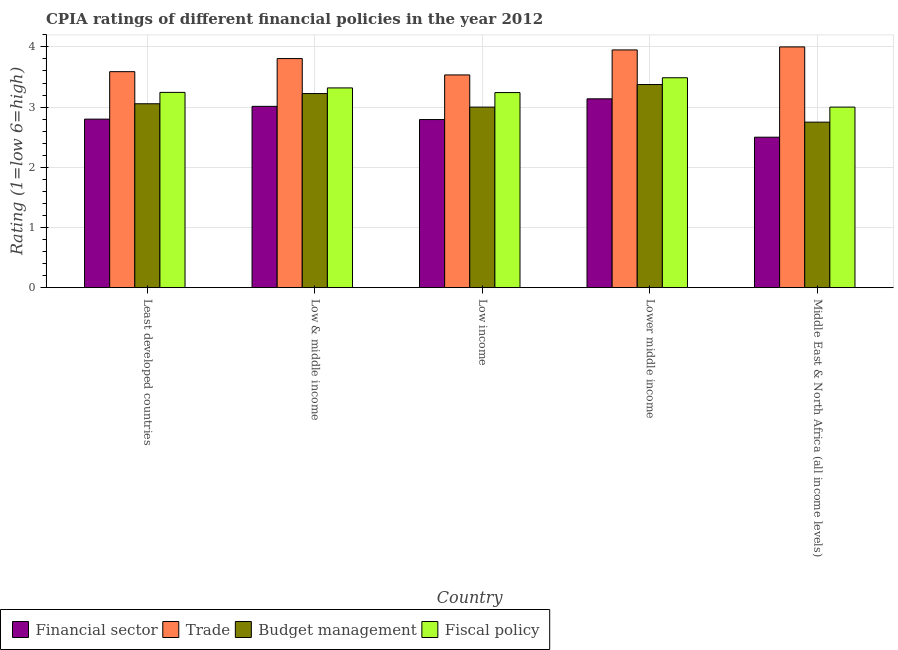Are the number of bars on each tick of the X-axis equal?
Keep it short and to the point. Yes. How many bars are there on the 4th tick from the left?
Ensure brevity in your answer.  4. In how many cases, is the number of bars for a given country not equal to the number of legend labels?
Make the answer very short. 0. What is the cpia rating of fiscal policy in Least developed countries?
Offer a very short reply. 3.24. Across all countries, what is the maximum cpia rating of fiscal policy?
Offer a very short reply. 3.49. Across all countries, what is the minimum cpia rating of fiscal policy?
Keep it short and to the point. 3. In which country was the cpia rating of financial sector maximum?
Ensure brevity in your answer.  Lower middle income. In which country was the cpia rating of financial sector minimum?
Your response must be concise. Middle East & North Africa (all income levels). What is the total cpia rating of trade in the graph?
Offer a very short reply. 18.88. What is the difference between the cpia rating of budget management in Low & middle income and that in Lower middle income?
Provide a short and direct response. -0.15. What is the difference between the cpia rating of fiscal policy in Low & middle income and the cpia rating of trade in Middle East & North Africa (all income levels)?
Offer a very short reply. -0.68. What is the average cpia rating of financial sector per country?
Your answer should be very brief. 2.85. What is the difference between the cpia rating of fiscal policy and cpia rating of financial sector in Low income?
Offer a terse response. 0.45. In how many countries, is the cpia rating of fiscal policy greater than 0.4 ?
Offer a very short reply. 5. What is the ratio of the cpia rating of trade in Least developed countries to that in Lower middle income?
Give a very brief answer. 0.91. What is the difference between the highest and the second highest cpia rating of trade?
Make the answer very short. 0.05. What is the difference between the highest and the lowest cpia rating of trade?
Provide a short and direct response. 0.47. What does the 3rd bar from the left in Low & middle income represents?
Ensure brevity in your answer.  Budget management. What does the 1st bar from the right in Lower middle income represents?
Provide a short and direct response. Fiscal policy. Is it the case that in every country, the sum of the cpia rating of financial sector and cpia rating of trade is greater than the cpia rating of budget management?
Your response must be concise. Yes. How many bars are there?
Provide a short and direct response. 20. Are all the bars in the graph horizontal?
Give a very brief answer. No. What is the difference between two consecutive major ticks on the Y-axis?
Your response must be concise. 1. Are the values on the major ticks of Y-axis written in scientific E-notation?
Provide a succinct answer. No. How are the legend labels stacked?
Your answer should be very brief. Horizontal. What is the title of the graph?
Provide a succinct answer. CPIA ratings of different financial policies in the year 2012. What is the label or title of the X-axis?
Offer a terse response. Country. What is the label or title of the Y-axis?
Ensure brevity in your answer.  Rating (1=low 6=high). What is the Rating (1=low 6=high) in Financial sector in Least developed countries?
Give a very brief answer. 2.8. What is the Rating (1=low 6=high) of Trade in Least developed countries?
Your answer should be compact. 3.59. What is the Rating (1=low 6=high) in Budget management in Least developed countries?
Offer a terse response. 3.06. What is the Rating (1=low 6=high) in Fiscal policy in Least developed countries?
Offer a very short reply. 3.24. What is the Rating (1=low 6=high) of Financial sector in Low & middle income?
Ensure brevity in your answer.  3.01. What is the Rating (1=low 6=high) in Trade in Low & middle income?
Your answer should be compact. 3.81. What is the Rating (1=low 6=high) in Budget management in Low & middle income?
Your answer should be compact. 3.23. What is the Rating (1=low 6=high) in Fiscal policy in Low & middle income?
Offer a terse response. 3.32. What is the Rating (1=low 6=high) in Financial sector in Low income?
Your response must be concise. 2.79. What is the Rating (1=low 6=high) in Trade in Low income?
Give a very brief answer. 3.53. What is the Rating (1=low 6=high) of Budget management in Low income?
Give a very brief answer. 3. What is the Rating (1=low 6=high) in Fiscal policy in Low income?
Provide a succinct answer. 3.24. What is the Rating (1=low 6=high) in Financial sector in Lower middle income?
Provide a succinct answer. 3.14. What is the Rating (1=low 6=high) of Trade in Lower middle income?
Your answer should be compact. 3.95. What is the Rating (1=low 6=high) of Budget management in Lower middle income?
Provide a succinct answer. 3.38. What is the Rating (1=low 6=high) in Fiscal policy in Lower middle income?
Provide a short and direct response. 3.49. What is the Rating (1=low 6=high) of Budget management in Middle East & North Africa (all income levels)?
Keep it short and to the point. 2.75. Across all countries, what is the maximum Rating (1=low 6=high) of Financial sector?
Provide a succinct answer. 3.14. Across all countries, what is the maximum Rating (1=low 6=high) in Trade?
Offer a terse response. 4. Across all countries, what is the maximum Rating (1=low 6=high) in Budget management?
Make the answer very short. 3.38. Across all countries, what is the maximum Rating (1=low 6=high) in Fiscal policy?
Your answer should be very brief. 3.49. Across all countries, what is the minimum Rating (1=low 6=high) of Trade?
Ensure brevity in your answer.  3.53. Across all countries, what is the minimum Rating (1=low 6=high) in Budget management?
Make the answer very short. 2.75. What is the total Rating (1=low 6=high) of Financial sector in the graph?
Provide a short and direct response. 14.24. What is the total Rating (1=low 6=high) of Trade in the graph?
Give a very brief answer. 18.88. What is the total Rating (1=low 6=high) in Budget management in the graph?
Ensure brevity in your answer.  15.41. What is the total Rating (1=low 6=high) of Fiscal policy in the graph?
Make the answer very short. 16.29. What is the difference between the Rating (1=low 6=high) in Financial sector in Least developed countries and that in Low & middle income?
Offer a terse response. -0.21. What is the difference between the Rating (1=low 6=high) of Trade in Least developed countries and that in Low & middle income?
Your answer should be very brief. -0.22. What is the difference between the Rating (1=low 6=high) in Budget management in Least developed countries and that in Low & middle income?
Offer a terse response. -0.17. What is the difference between the Rating (1=low 6=high) of Fiscal policy in Least developed countries and that in Low & middle income?
Your answer should be very brief. -0.07. What is the difference between the Rating (1=low 6=high) of Financial sector in Least developed countries and that in Low income?
Offer a terse response. 0.01. What is the difference between the Rating (1=low 6=high) in Trade in Least developed countries and that in Low income?
Ensure brevity in your answer.  0.05. What is the difference between the Rating (1=low 6=high) in Budget management in Least developed countries and that in Low income?
Provide a short and direct response. 0.06. What is the difference between the Rating (1=low 6=high) of Fiscal policy in Least developed countries and that in Low income?
Ensure brevity in your answer.  0. What is the difference between the Rating (1=low 6=high) in Financial sector in Least developed countries and that in Lower middle income?
Make the answer very short. -0.34. What is the difference between the Rating (1=low 6=high) in Trade in Least developed countries and that in Lower middle income?
Give a very brief answer. -0.36. What is the difference between the Rating (1=low 6=high) of Budget management in Least developed countries and that in Lower middle income?
Keep it short and to the point. -0.32. What is the difference between the Rating (1=low 6=high) in Fiscal policy in Least developed countries and that in Lower middle income?
Your answer should be very brief. -0.24. What is the difference between the Rating (1=low 6=high) of Trade in Least developed countries and that in Middle East & North Africa (all income levels)?
Give a very brief answer. -0.41. What is the difference between the Rating (1=low 6=high) of Budget management in Least developed countries and that in Middle East & North Africa (all income levels)?
Make the answer very short. 0.31. What is the difference between the Rating (1=low 6=high) in Fiscal policy in Least developed countries and that in Middle East & North Africa (all income levels)?
Provide a short and direct response. 0.24. What is the difference between the Rating (1=low 6=high) of Financial sector in Low & middle income and that in Low income?
Give a very brief answer. 0.22. What is the difference between the Rating (1=low 6=high) of Trade in Low & middle income and that in Low income?
Make the answer very short. 0.27. What is the difference between the Rating (1=low 6=high) of Budget management in Low & middle income and that in Low income?
Ensure brevity in your answer.  0.23. What is the difference between the Rating (1=low 6=high) of Fiscal policy in Low & middle income and that in Low income?
Give a very brief answer. 0.08. What is the difference between the Rating (1=low 6=high) in Financial sector in Low & middle income and that in Lower middle income?
Make the answer very short. -0.12. What is the difference between the Rating (1=low 6=high) in Trade in Low & middle income and that in Lower middle income?
Make the answer very short. -0.14. What is the difference between the Rating (1=low 6=high) in Budget management in Low & middle income and that in Lower middle income?
Provide a succinct answer. -0.15. What is the difference between the Rating (1=low 6=high) of Fiscal policy in Low & middle income and that in Lower middle income?
Provide a succinct answer. -0.17. What is the difference between the Rating (1=low 6=high) of Financial sector in Low & middle income and that in Middle East & North Africa (all income levels)?
Ensure brevity in your answer.  0.51. What is the difference between the Rating (1=low 6=high) of Trade in Low & middle income and that in Middle East & North Africa (all income levels)?
Your answer should be compact. -0.19. What is the difference between the Rating (1=low 6=high) in Budget management in Low & middle income and that in Middle East & North Africa (all income levels)?
Make the answer very short. 0.47. What is the difference between the Rating (1=low 6=high) of Fiscal policy in Low & middle income and that in Middle East & North Africa (all income levels)?
Offer a terse response. 0.32. What is the difference between the Rating (1=low 6=high) of Financial sector in Low income and that in Lower middle income?
Ensure brevity in your answer.  -0.34. What is the difference between the Rating (1=low 6=high) in Trade in Low income and that in Lower middle income?
Offer a terse response. -0.42. What is the difference between the Rating (1=low 6=high) in Budget management in Low income and that in Lower middle income?
Offer a very short reply. -0.38. What is the difference between the Rating (1=low 6=high) of Fiscal policy in Low income and that in Lower middle income?
Offer a terse response. -0.25. What is the difference between the Rating (1=low 6=high) in Financial sector in Low income and that in Middle East & North Africa (all income levels)?
Your answer should be compact. 0.29. What is the difference between the Rating (1=low 6=high) of Trade in Low income and that in Middle East & North Africa (all income levels)?
Give a very brief answer. -0.47. What is the difference between the Rating (1=low 6=high) in Budget management in Low income and that in Middle East & North Africa (all income levels)?
Ensure brevity in your answer.  0.25. What is the difference between the Rating (1=low 6=high) in Fiscal policy in Low income and that in Middle East & North Africa (all income levels)?
Ensure brevity in your answer.  0.24. What is the difference between the Rating (1=low 6=high) of Financial sector in Lower middle income and that in Middle East & North Africa (all income levels)?
Your answer should be compact. 0.64. What is the difference between the Rating (1=low 6=high) of Trade in Lower middle income and that in Middle East & North Africa (all income levels)?
Offer a terse response. -0.05. What is the difference between the Rating (1=low 6=high) in Budget management in Lower middle income and that in Middle East & North Africa (all income levels)?
Provide a succinct answer. 0.62. What is the difference between the Rating (1=low 6=high) of Fiscal policy in Lower middle income and that in Middle East & North Africa (all income levels)?
Give a very brief answer. 0.49. What is the difference between the Rating (1=low 6=high) in Financial sector in Least developed countries and the Rating (1=low 6=high) in Trade in Low & middle income?
Ensure brevity in your answer.  -1.01. What is the difference between the Rating (1=low 6=high) of Financial sector in Least developed countries and the Rating (1=low 6=high) of Budget management in Low & middle income?
Offer a very short reply. -0.42. What is the difference between the Rating (1=low 6=high) of Financial sector in Least developed countries and the Rating (1=low 6=high) of Fiscal policy in Low & middle income?
Your answer should be compact. -0.52. What is the difference between the Rating (1=low 6=high) of Trade in Least developed countries and the Rating (1=low 6=high) of Budget management in Low & middle income?
Keep it short and to the point. 0.36. What is the difference between the Rating (1=low 6=high) in Trade in Least developed countries and the Rating (1=low 6=high) in Fiscal policy in Low & middle income?
Offer a very short reply. 0.27. What is the difference between the Rating (1=low 6=high) in Budget management in Least developed countries and the Rating (1=low 6=high) in Fiscal policy in Low & middle income?
Your answer should be compact. -0.26. What is the difference between the Rating (1=low 6=high) in Financial sector in Least developed countries and the Rating (1=low 6=high) in Trade in Low income?
Give a very brief answer. -0.73. What is the difference between the Rating (1=low 6=high) in Financial sector in Least developed countries and the Rating (1=low 6=high) in Budget management in Low income?
Your answer should be compact. -0.2. What is the difference between the Rating (1=low 6=high) of Financial sector in Least developed countries and the Rating (1=low 6=high) of Fiscal policy in Low income?
Offer a terse response. -0.44. What is the difference between the Rating (1=low 6=high) of Trade in Least developed countries and the Rating (1=low 6=high) of Budget management in Low income?
Ensure brevity in your answer.  0.59. What is the difference between the Rating (1=low 6=high) in Trade in Least developed countries and the Rating (1=low 6=high) in Fiscal policy in Low income?
Your answer should be very brief. 0.35. What is the difference between the Rating (1=low 6=high) of Budget management in Least developed countries and the Rating (1=low 6=high) of Fiscal policy in Low income?
Offer a very short reply. -0.19. What is the difference between the Rating (1=low 6=high) in Financial sector in Least developed countries and the Rating (1=low 6=high) in Trade in Lower middle income?
Your answer should be very brief. -1.15. What is the difference between the Rating (1=low 6=high) of Financial sector in Least developed countries and the Rating (1=low 6=high) of Budget management in Lower middle income?
Keep it short and to the point. -0.57. What is the difference between the Rating (1=low 6=high) in Financial sector in Least developed countries and the Rating (1=low 6=high) in Fiscal policy in Lower middle income?
Provide a succinct answer. -0.69. What is the difference between the Rating (1=low 6=high) of Trade in Least developed countries and the Rating (1=low 6=high) of Budget management in Lower middle income?
Provide a succinct answer. 0.21. What is the difference between the Rating (1=low 6=high) of Trade in Least developed countries and the Rating (1=low 6=high) of Fiscal policy in Lower middle income?
Give a very brief answer. 0.1. What is the difference between the Rating (1=low 6=high) of Budget management in Least developed countries and the Rating (1=low 6=high) of Fiscal policy in Lower middle income?
Provide a succinct answer. -0.43. What is the difference between the Rating (1=low 6=high) in Financial sector in Least developed countries and the Rating (1=low 6=high) in Trade in Middle East & North Africa (all income levels)?
Ensure brevity in your answer.  -1.2. What is the difference between the Rating (1=low 6=high) of Financial sector in Least developed countries and the Rating (1=low 6=high) of Budget management in Middle East & North Africa (all income levels)?
Ensure brevity in your answer.  0.05. What is the difference between the Rating (1=low 6=high) in Trade in Least developed countries and the Rating (1=low 6=high) in Budget management in Middle East & North Africa (all income levels)?
Ensure brevity in your answer.  0.84. What is the difference between the Rating (1=low 6=high) in Trade in Least developed countries and the Rating (1=low 6=high) in Fiscal policy in Middle East & North Africa (all income levels)?
Your response must be concise. 0.59. What is the difference between the Rating (1=low 6=high) of Budget management in Least developed countries and the Rating (1=low 6=high) of Fiscal policy in Middle East & North Africa (all income levels)?
Ensure brevity in your answer.  0.06. What is the difference between the Rating (1=low 6=high) of Financial sector in Low & middle income and the Rating (1=low 6=high) of Trade in Low income?
Provide a succinct answer. -0.52. What is the difference between the Rating (1=low 6=high) of Financial sector in Low & middle income and the Rating (1=low 6=high) of Budget management in Low income?
Make the answer very short. 0.01. What is the difference between the Rating (1=low 6=high) of Financial sector in Low & middle income and the Rating (1=low 6=high) of Fiscal policy in Low income?
Provide a short and direct response. -0.23. What is the difference between the Rating (1=low 6=high) in Trade in Low & middle income and the Rating (1=low 6=high) in Budget management in Low income?
Give a very brief answer. 0.81. What is the difference between the Rating (1=low 6=high) in Trade in Low & middle income and the Rating (1=low 6=high) in Fiscal policy in Low income?
Your answer should be compact. 0.56. What is the difference between the Rating (1=low 6=high) of Budget management in Low & middle income and the Rating (1=low 6=high) of Fiscal policy in Low income?
Your response must be concise. -0.02. What is the difference between the Rating (1=low 6=high) of Financial sector in Low & middle income and the Rating (1=low 6=high) of Trade in Lower middle income?
Give a very brief answer. -0.94. What is the difference between the Rating (1=low 6=high) of Financial sector in Low & middle income and the Rating (1=low 6=high) of Budget management in Lower middle income?
Provide a succinct answer. -0.36. What is the difference between the Rating (1=low 6=high) of Financial sector in Low & middle income and the Rating (1=low 6=high) of Fiscal policy in Lower middle income?
Keep it short and to the point. -0.47. What is the difference between the Rating (1=low 6=high) in Trade in Low & middle income and the Rating (1=low 6=high) in Budget management in Lower middle income?
Keep it short and to the point. 0.43. What is the difference between the Rating (1=low 6=high) of Trade in Low & middle income and the Rating (1=low 6=high) of Fiscal policy in Lower middle income?
Your answer should be compact. 0.32. What is the difference between the Rating (1=low 6=high) in Budget management in Low & middle income and the Rating (1=low 6=high) in Fiscal policy in Lower middle income?
Your answer should be compact. -0.26. What is the difference between the Rating (1=low 6=high) in Financial sector in Low & middle income and the Rating (1=low 6=high) in Trade in Middle East & North Africa (all income levels)?
Your answer should be compact. -0.99. What is the difference between the Rating (1=low 6=high) of Financial sector in Low & middle income and the Rating (1=low 6=high) of Budget management in Middle East & North Africa (all income levels)?
Provide a succinct answer. 0.26. What is the difference between the Rating (1=low 6=high) of Financial sector in Low & middle income and the Rating (1=low 6=high) of Fiscal policy in Middle East & North Africa (all income levels)?
Give a very brief answer. 0.01. What is the difference between the Rating (1=low 6=high) of Trade in Low & middle income and the Rating (1=low 6=high) of Budget management in Middle East & North Africa (all income levels)?
Provide a short and direct response. 1.06. What is the difference between the Rating (1=low 6=high) in Trade in Low & middle income and the Rating (1=low 6=high) in Fiscal policy in Middle East & North Africa (all income levels)?
Offer a very short reply. 0.81. What is the difference between the Rating (1=low 6=high) of Budget management in Low & middle income and the Rating (1=low 6=high) of Fiscal policy in Middle East & North Africa (all income levels)?
Offer a terse response. 0.23. What is the difference between the Rating (1=low 6=high) of Financial sector in Low income and the Rating (1=low 6=high) of Trade in Lower middle income?
Provide a succinct answer. -1.16. What is the difference between the Rating (1=low 6=high) of Financial sector in Low income and the Rating (1=low 6=high) of Budget management in Lower middle income?
Offer a very short reply. -0.58. What is the difference between the Rating (1=low 6=high) in Financial sector in Low income and the Rating (1=low 6=high) in Fiscal policy in Lower middle income?
Ensure brevity in your answer.  -0.69. What is the difference between the Rating (1=low 6=high) in Trade in Low income and the Rating (1=low 6=high) in Budget management in Lower middle income?
Provide a succinct answer. 0.16. What is the difference between the Rating (1=low 6=high) in Trade in Low income and the Rating (1=low 6=high) in Fiscal policy in Lower middle income?
Provide a succinct answer. 0.05. What is the difference between the Rating (1=low 6=high) in Budget management in Low income and the Rating (1=low 6=high) in Fiscal policy in Lower middle income?
Keep it short and to the point. -0.49. What is the difference between the Rating (1=low 6=high) in Financial sector in Low income and the Rating (1=low 6=high) in Trade in Middle East & North Africa (all income levels)?
Offer a very short reply. -1.21. What is the difference between the Rating (1=low 6=high) of Financial sector in Low income and the Rating (1=low 6=high) of Budget management in Middle East & North Africa (all income levels)?
Offer a very short reply. 0.04. What is the difference between the Rating (1=low 6=high) in Financial sector in Low income and the Rating (1=low 6=high) in Fiscal policy in Middle East & North Africa (all income levels)?
Your answer should be compact. -0.21. What is the difference between the Rating (1=low 6=high) of Trade in Low income and the Rating (1=low 6=high) of Budget management in Middle East & North Africa (all income levels)?
Offer a very short reply. 0.78. What is the difference between the Rating (1=low 6=high) in Trade in Low income and the Rating (1=low 6=high) in Fiscal policy in Middle East & North Africa (all income levels)?
Give a very brief answer. 0.53. What is the difference between the Rating (1=low 6=high) of Budget management in Low income and the Rating (1=low 6=high) of Fiscal policy in Middle East & North Africa (all income levels)?
Provide a succinct answer. 0. What is the difference between the Rating (1=low 6=high) of Financial sector in Lower middle income and the Rating (1=low 6=high) of Trade in Middle East & North Africa (all income levels)?
Offer a terse response. -0.86. What is the difference between the Rating (1=low 6=high) in Financial sector in Lower middle income and the Rating (1=low 6=high) in Budget management in Middle East & North Africa (all income levels)?
Your response must be concise. 0.39. What is the difference between the Rating (1=low 6=high) of Financial sector in Lower middle income and the Rating (1=low 6=high) of Fiscal policy in Middle East & North Africa (all income levels)?
Give a very brief answer. 0.14. What is the difference between the Rating (1=low 6=high) of Trade in Lower middle income and the Rating (1=low 6=high) of Fiscal policy in Middle East & North Africa (all income levels)?
Provide a short and direct response. 0.95. What is the average Rating (1=low 6=high) of Financial sector per country?
Provide a short and direct response. 2.85. What is the average Rating (1=low 6=high) in Trade per country?
Provide a succinct answer. 3.78. What is the average Rating (1=low 6=high) of Budget management per country?
Keep it short and to the point. 3.08. What is the average Rating (1=low 6=high) in Fiscal policy per country?
Provide a short and direct response. 3.26. What is the difference between the Rating (1=low 6=high) in Financial sector and Rating (1=low 6=high) in Trade in Least developed countries?
Offer a terse response. -0.79. What is the difference between the Rating (1=low 6=high) of Financial sector and Rating (1=low 6=high) of Budget management in Least developed countries?
Your response must be concise. -0.26. What is the difference between the Rating (1=low 6=high) of Financial sector and Rating (1=low 6=high) of Fiscal policy in Least developed countries?
Make the answer very short. -0.44. What is the difference between the Rating (1=low 6=high) in Trade and Rating (1=low 6=high) in Budget management in Least developed countries?
Ensure brevity in your answer.  0.53. What is the difference between the Rating (1=low 6=high) of Trade and Rating (1=low 6=high) of Fiscal policy in Least developed countries?
Offer a very short reply. 0.34. What is the difference between the Rating (1=low 6=high) of Budget management and Rating (1=low 6=high) of Fiscal policy in Least developed countries?
Make the answer very short. -0.19. What is the difference between the Rating (1=low 6=high) of Financial sector and Rating (1=low 6=high) of Trade in Low & middle income?
Make the answer very short. -0.79. What is the difference between the Rating (1=low 6=high) of Financial sector and Rating (1=low 6=high) of Budget management in Low & middle income?
Your answer should be compact. -0.21. What is the difference between the Rating (1=low 6=high) of Financial sector and Rating (1=low 6=high) of Fiscal policy in Low & middle income?
Ensure brevity in your answer.  -0.31. What is the difference between the Rating (1=low 6=high) of Trade and Rating (1=low 6=high) of Budget management in Low & middle income?
Provide a succinct answer. 0.58. What is the difference between the Rating (1=low 6=high) in Trade and Rating (1=low 6=high) in Fiscal policy in Low & middle income?
Your response must be concise. 0.49. What is the difference between the Rating (1=low 6=high) of Budget management and Rating (1=low 6=high) of Fiscal policy in Low & middle income?
Ensure brevity in your answer.  -0.09. What is the difference between the Rating (1=low 6=high) of Financial sector and Rating (1=low 6=high) of Trade in Low income?
Give a very brief answer. -0.74. What is the difference between the Rating (1=low 6=high) in Financial sector and Rating (1=low 6=high) in Budget management in Low income?
Your answer should be very brief. -0.21. What is the difference between the Rating (1=low 6=high) of Financial sector and Rating (1=low 6=high) of Fiscal policy in Low income?
Provide a succinct answer. -0.45. What is the difference between the Rating (1=low 6=high) in Trade and Rating (1=low 6=high) in Budget management in Low income?
Ensure brevity in your answer.  0.53. What is the difference between the Rating (1=low 6=high) in Trade and Rating (1=low 6=high) in Fiscal policy in Low income?
Offer a very short reply. 0.29. What is the difference between the Rating (1=low 6=high) of Budget management and Rating (1=low 6=high) of Fiscal policy in Low income?
Keep it short and to the point. -0.24. What is the difference between the Rating (1=low 6=high) in Financial sector and Rating (1=low 6=high) in Trade in Lower middle income?
Ensure brevity in your answer.  -0.81. What is the difference between the Rating (1=low 6=high) of Financial sector and Rating (1=low 6=high) of Budget management in Lower middle income?
Your answer should be compact. -0.24. What is the difference between the Rating (1=low 6=high) in Financial sector and Rating (1=low 6=high) in Fiscal policy in Lower middle income?
Your answer should be compact. -0.35. What is the difference between the Rating (1=low 6=high) in Trade and Rating (1=low 6=high) in Budget management in Lower middle income?
Make the answer very short. 0.57. What is the difference between the Rating (1=low 6=high) in Trade and Rating (1=low 6=high) in Fiscal policy in Lower middle income?
Provide a succinct answer. 0.46. What is the difference between the Rating (1=low 6=high) in Budget management and Rating (1=low 6=high) in Fiscal policy in Lower middle income?
Offer a very short reply. -0.11. What is the difference between the Rating (1=low 6=high) in Financial sector and Rating (1=low 6=high) in Trade in Middle East & North Africa (all income levels)?
Keep it short and to the point. -1.5. What is the difference between the Rating (1=low 6=high) of Financial sector and Rating (1=low 6=high) of Budget management in Middle East & North Africa (all income levels)?
Give a very brief answer. -0.25. What is the difference between the Rating (1=low 6=high) in Budget management and Rating (1=low 6=high) in Fiscal policy in Middle East & North Africa (all income levels)?
Offer a very short reply. -0.25. What is the ratio of the Rating (1=low 6=high) in Financial sector in Least developed countries to that in Low & middle income?
Your answer should be very brief. 0.93. What is the ratio of the Rating (1=low 6=high) in Trade in Least developed countries to that in Low & middle income?
Ensure brevity in your answer.  0.94. What is the ratio of the Rating (1=low 6=high) of Budget management in Least developed countries to that in Low & middle income?
Provide a short and direct response. 0.95. What is the ratio of the Rating (1=low 6=high) in Fiscal policy in Least developed countries to that in Low & middle income?
Provide a short and direct response. 0.98. What is the ratio of the Rating (1=low 6=high) in Financial sector in Least developed countries to that in Low income?
Keep it short and to the point. 1. What is the ratio of the Rating (1=low 6=high) of Trade in Least developed countries to that in Low income?
Your answer should be very brief. 1.02. What is the ratio of the Rating (1=low 6=high) in Budget management in Least developed countries to that in Low income?
Offer a terse response. 1.02. What is the ratio of the Rating (1=low 6=high) in Fiscal policy in Least developed countries to that in Low income?
Offer a terse response. 1. What is the ratio of the Rating (1=low 6=high) in Financial sector in Least developed countries to that in Lower middle income?
Make the answer very short. 0.89. What is the ratio of the Rating (1=low 6=high) in Trade in Least developed countries to that in Lower middle income?
Your answer should be compact. 0.91. What is the ratio of the Rating (1=low 6=high) of Budget management in Least developed countries to that in Lower middle income?
Your response must be concise. 0.91. What is the ratio of the Rating (1=low 6=high) of Fiscal policy in Least developed countries to that in Lower middle income?
Offer a very short reply. 0.93. What is the ratio of the Rating (1=low 6=high) of Financial sector in Least developed countries to that in Middle East & North Africa (all income levels)?
Make the answer very short. 1.12. What is the ratio of the Rating (1=low 6=high) of Trade in Least developed countries to that in Middle East & North Africa (all income levels)?
Provide a succinct answer. 0.9. What is the ratio of the Rating (1=low 6=high) of Budget management in Least developed countries to that in Middle East & North Africa (all income levels)?
Your response must be concise. 1.11. What is the ratio of the Rating (1=low 6=high) of Fiscal policy in Least developed countries to that in Middle East & North Africa (all income levels)?
Give a very brief answer. 1.08. What is the ratio of the Rating (1=low 6=high) of Financial sector in Low & middle income to that in Low income?
Give a very brief answer. 1.08. What is the ratio of the Rating (1=low 6=high) of Budget management in Low & middle income to that in Low income?
Offer a very short reply. 1.07. What is the ratio of the Rating (1=low 6=high) of Fiscal policy in Low & middle income to that in Low income?
Keep it short and to the point. 1.02. What is the ratio of the Rating (1=low 6=high) of Financial sector in Low & middle income to that in Lower middle income?
Your response must be concise. 0.96. What is the ratio of the Rating (1=low 6=high) in Trade in Low & middle income to that in Lower middle income?
Provide a succinct answer. 0.96. What is the ratio of the Rating (1=low 6=high) in Budget management in Low & middle income to that in Lower middle income?
Provide a short and direct response. 0.96. What is the ratio of the Rating (1=low 6=high) of Fiscal policy in Low & middle income to that in Lower middle income?
Your answer should be compact. 0.95. What is the ratio of the Rating (1=low 6=high) of Financial sector in Low & middle income to that in Middle East & North Africa (all income levels)?
Provide a short and direct response. 1.21. What is the ratio of the Rating (1=low 6=high) of Trade in Low & middle income to that in Middle East & North Africa (all income levels)?
Offer a terse response. 0.95. What is the ratio of the Rating (1=low 6=high) of Budget management in Low & middle income to that in Middle East & North Africa (all income levels)?
Provide a succinct answer. 1.17. What is the ratio of the Rating (1=low 6=high) in Fiscal policy in Low & middle income to that in Middle East & North Africa (all income levels)?
Keep it short and to the point. 1.11. What is the ratio of the Rating (1=low 6=high) in Financial sector in Low income to that in Lower middle income?
Give a very brief answer. 0.89. What is the ratio of the Rating (1=low 6=high) in Trade in Low income to that in Lower middle income?
Give a very brief answer. 0.89. What is the ratio of the Rating (1=low 6=high) of Fiscal policy in Low income to that in Lower middle income?
Offer a terse response. 0.93. What is the ratio of the Rating (1=low 6=high) in Financial sector in Low income to that in Middle East & North Africa (all income levels)?
Make the answer very short. 1.12. What is the ratio of the Rating (1=low 6=high) in Trade in Low income to that in Middle East & North Africa (all income levels)?
Give a very brief answer. 0.88. What is the ratio of the Rating (1=low 6=high) in Fiscal policy in Low income to that in Middle East & North Africa (all income levels)?
Ensure brevity in your answer.  1.08. What is the ratio of the Rating (1=low 6=high) of Financial sector in Lower middle income to that in Middle East & North Africa (all income levels)?
Ensure brevity in your answer.  1.25. What is the ratio of the Rating (1=low 6=high) in Trade in Lower middle income to that in Middle East & North Africa (all income levels)?
Your response must be concise. 0.99. What is the ratio of the Rating (1=low 6=high) of Budget management in Lower middle income to that in Middle East & North Africa (all income levels)?
Keep it short and to the point. 1.23. What is the ratio of the Rating (1=low 6=high) in Fiscal policy in Lower middle income to that in Middle East & North Africa (all income levels)?
Make the answer very short. 1.16. What is the difference between the highest and the second highest Rating (1=low 6=high) in Financial sector?
Offer a terse response. 0.12. What is the difference between the highest and the second highest Rating (1=low 6=high) in Trade?
Ensure brevity in your answer.  0.05. What is the difference between the highest and the second highest Rating (1=low 6=high) in Fiscal policy?
Make the answer very short. 0.17. What is the difference between the highest and the lowest Rating (1=low 6=high) of Financial sector?
Your answer should be very brief. 0.64. What is the difference between the highest and the lowest Rating (1=low 6=high) in Trade?
Offer a terse response. 0.47. What is the difference between the highest and the lowest Rating (1=low 6=high) in Fiscal policy?
Give a very brief answer. 0.49. 